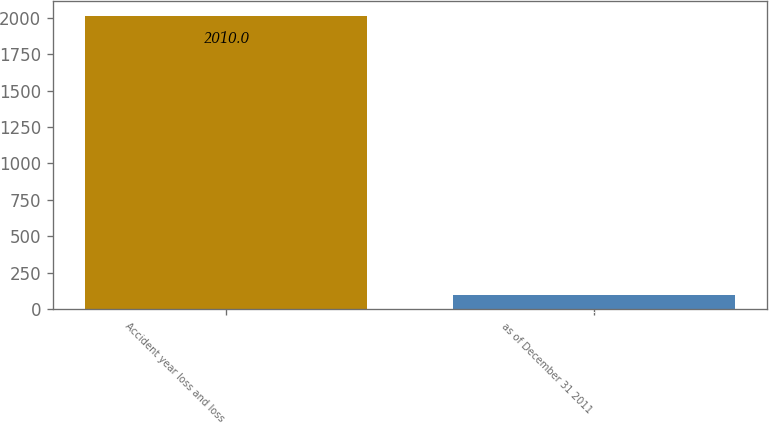<chart> <loc_0><loc_0><loc_500><loc_500><bar_chart><fcel>Accident year loss and loss<fcel>as of December 31 2011<nl><fcel>2010<fcel>96.3<nl></chart> 